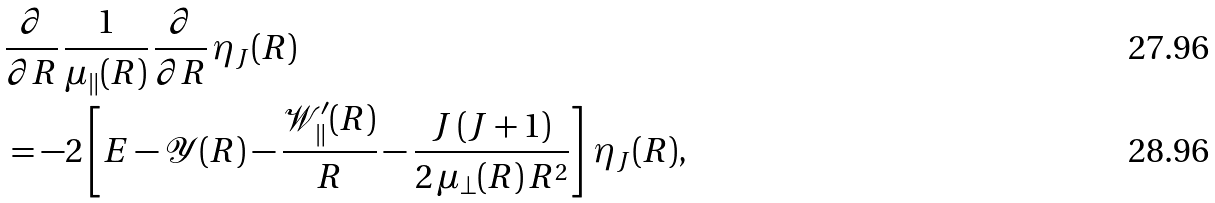<formula> <loc_0><loc_0><loc_500><loc_500>& \frac { \partial } { \partial R } \, \frac { 1 } { \mu _ { \| } ( R ) } \, \frac { \partial } { \partial R } \, \eta _ { J } ( R ) \\ & = - 2 \left [ E - \mathcal { Y } ( R ) - \frac { { \mathcal { W } } ^ { \prime } _ { \| } ( R ) } { R } - \frac { J \, ( J + 1 ) } { 2 \, \mu _ { \perp } ( R ) \, R ^ { 2 } } \right ] \, \eta _ { J } ( R ) ,</formula> 